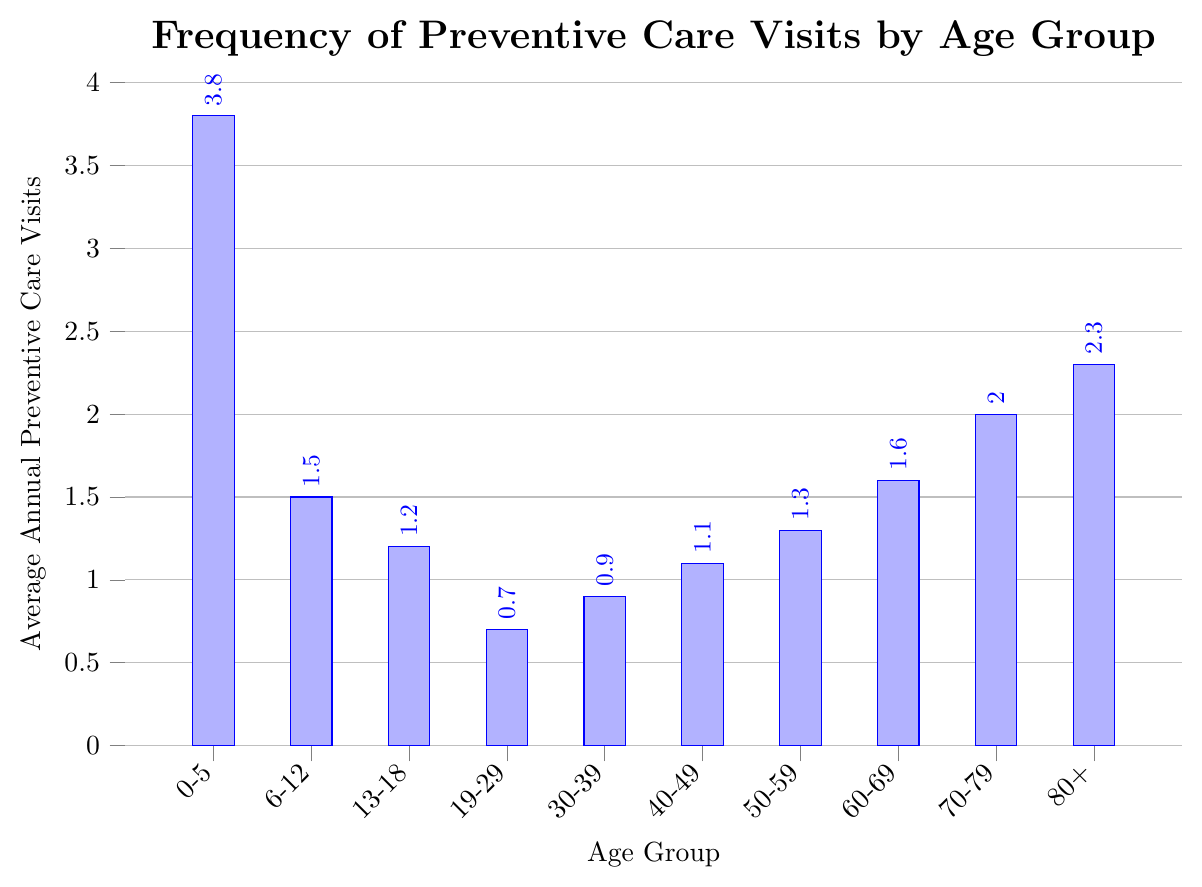What age group has the highest average annual preventive care visits? Scan the heights of the bars and identify the tallest bar which represents the highest average. The bar for the 0-5 years age group is the tallest.
Answer: 0-5 years What age group has the lowest average annual preventive care visits? Scan the heights of the bars and find the shortest bar. The bar for the 19-29 years age group is the shortest.
Answer: 19-29 years Which age group has more average annual preventive care visits, 40-49 years or 50-59 years? Compare the heights of the bars for the 40-49 and 50-59 years age groups. The bar for the 50-59 years is slightly taller.
Answer: 50-59 years What is the difference in average annual preventive care visits between the 0-5 years and 19-29 years age groups? Note the values of the 0-5 years and 19-29 years age groups (3.8 and 0.7 respectively), then subtract the smaller value from the larger one: 3.8 - 0.7.
Answer: 3.1 What is the total number of average annual preventive care visits for age groups 60-69, 70-79, and 80+ combined? Sum the average visits for the three age groups: 1.6 (60-69 years) + 2.0 (70-79 years) + 2.3 (80+ years).
Answer: 5.9 Which age group falls between the 30-39 and 50-59 years age groups in average annual preventive care visits? Compare the values of the age groups 30-39 (0.9), 40-49 (1.1), and 50-59 (1.3). Identify the age group that falls between the values of 0.9 and 1.3.
Answer: 40-49 years How does the average annual preventive care visits for 13-18 years compare to that for 6-12 years, and what is their ratio? Note the values: 1.2 (13-18 years) and 1.5 (6-12 years). Compare 1.2 to 1.5 (less). To find the ratio, divide 1.2 by 1.5.
Answer: Less, 0.8 What is the average of the average annual preventive care visits for all age groups combined? Sum the average visits for all age groups and then divide by the number of age groups: (3.8 + 1.5 + 1.2 + 0.7 + 0.9 + 1.1 + 1.3 + 1.6 + 2.0 + 2.3) / 10.
Answer: 1.64 What is the increase in average annual preventive care visits from the 60-69 years age group to the 70-79 years age group? Note the values for the 60-69 (1.6) and 70-79 years (2.0). Subtract the former from the latter: 2.0 - 1.6.
Answer: 0.4 Which two consecutive age groups have the largest difference in average annual preventive care visits? Calculate the differences between average visits for consecutive age groups and identify the largest one: (3.8 - 1.5 = 2.3) between 0-5 years and 6-12 years.
Answer: 0-5 and  6-12 years 